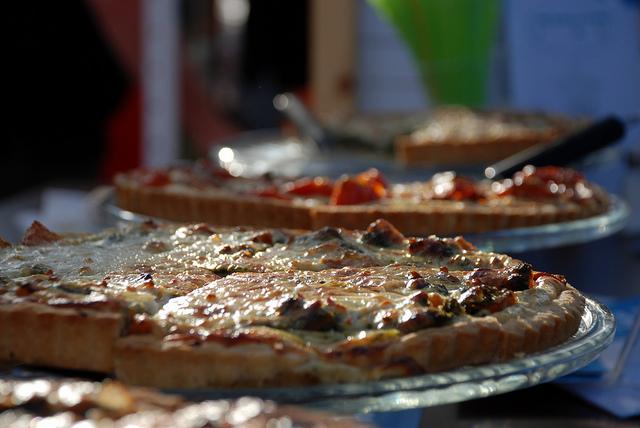Is this pizza?
Concise answer only. Yes. What kind of plate is holding the pizza?
Be succinct. Glass. What is on the pizza?
Write a very short answer. Sausage. 